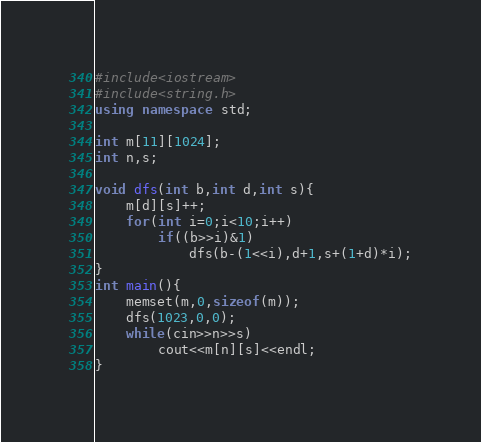<code> <loc_0><loc_0><loc_500><loc_500><_C++_>#include<iostream>
#include<string.h>
using namespace std;

int m[11][1024];
int n,s;

void dfs(int b,int d,int s){
    m[d][s]++;
    for(int i=0;i<10;i++)
        if((b>>i)&1)
            dfs(b-(1<<i),d+1,s+(1+d)*i);
}
int main(){
    memset(m,0,sizeof(m));
    dfs(1023,0,0);
    while(cin>>n>>s)
        cout<<m[n][s]<<endl;
}</code> 